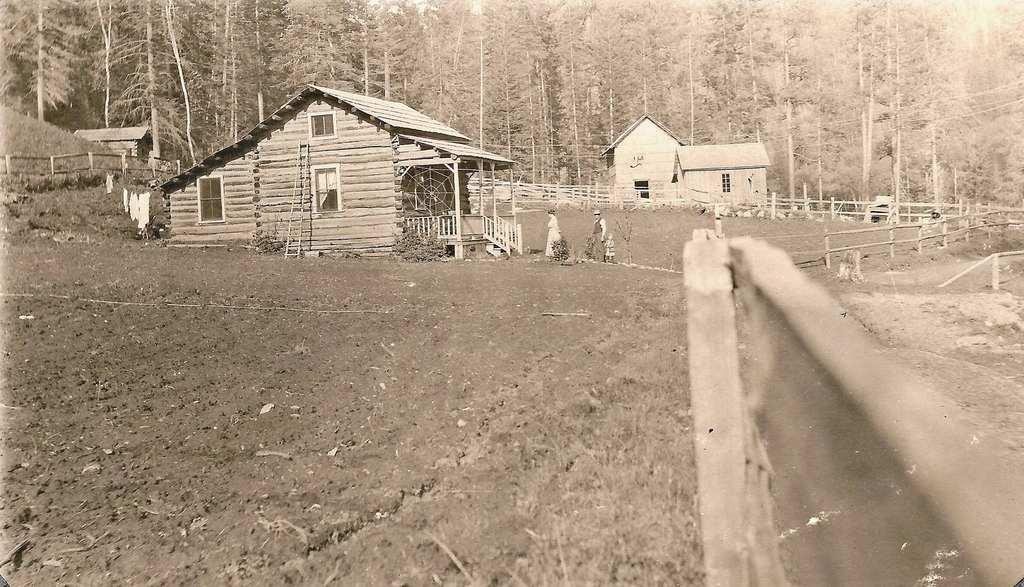What type of natural elements can be seen in the image? There are trees in the image. What type of structures are present in the image? There are houses in the image. Can you describe the people in the image? There are three people near a house in the image. What other living organisms can be seen in the image? There are plants in the image. What type of barrier is present in the image? There is a fence in the image. What additional object can be seen in the image? There is a ladder in the image. How much debt do the people in the image owe to the bank? There is no information about debt or banks in the image, so it cannot be determined. What type of pocket is visible on the ladder in the image? There is no pocket present on the ladder in the image. 